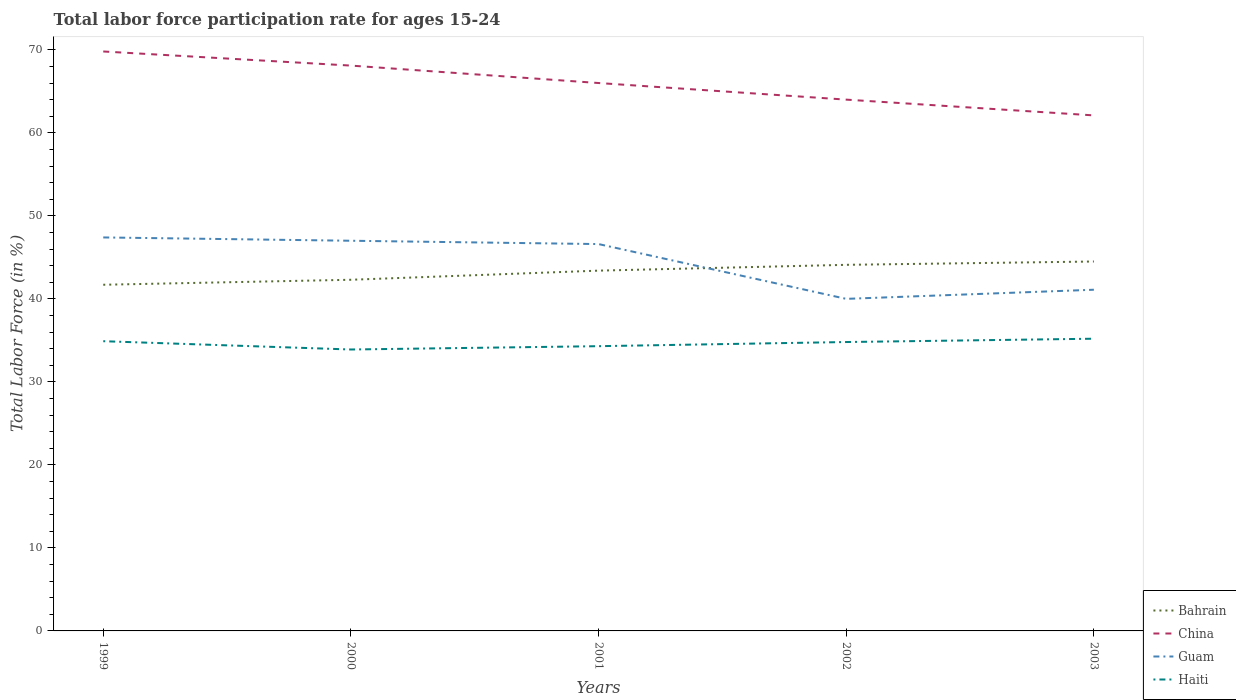How many different coloured lines are there?
Ensure brevity in your answer.  4. Is the number of lines equal to the number of legend labels?
Provide a succinct answer. Yes. Across all years, what is the maximum labor force participation rate in Bahrain?
Your answer should be compact. 41.7. In which year was the labor force participation rate in Guam maximum?
Your response must be concise. 2002. What is the total labor force participation rate in Haiti in the graph?
Offer a terse response. 0.6. What is the difference between the highest and the second highest labor force participation rate in Guam?
Offer a terse response. 7.4. What is the difference between the highest and the lowest labor force participation rate in China?
Offer a very short reply. 3. Is the labor force participation rate in China strictly greater than the labor force participation rate in Bahrain over the years?
Provide a succinct answer. No. How many years are there in the graph?
Provide a short and direct response. 5. What is the difference between two consecutive major ticks on the Y-axis?
Make the answer very short. 10. Are the values on the major ticks of Y-axis written in scientific E-notation?
Keep it short and to the point. No. Does the graph contain grids?
Your answer should be very brief. No. How many legend labels are there?
Provide a succinct answer. 4. How are the legend labels stacked?
Provide a succinct answer. Vertical. What is the title of the graph?
Give a very brief answer. Total labor force participation rate for ages 15-24. Does "Mexico" appear as one of the legend labels in the graph?
Provide a succinct answer. No. What is the Total Labor Force (in %) in Bahrain in 1999?
Your answer should be very brief. 41.7. What is the Total Labor Force (in %) in China in 1999?
Your answer should be compact. 69.8. What is the Total Labor Force (in %) of Guam in 1999?
Ensure brevity in your answer.  47.4. What is the Total Labor Force (in %) in Haiti in 1999?
Your answer should be very brief. 34.9. What is the Total Labor Force (in %) of Bahrain in 2000?
Your response must be concise. 42.3. What is the Total Labor Force (in %) in China in 2000?
Your response must be concise. 68.1. What is the Total Labor Force (in %) in Haiti in 2000?
Ensure brevity in your answer.  33.9. What is the Total Labor Force (in %) in Bahrain in 2001?
Provide a succinct answer. 43.4. What is the Total Labor Force (in %) in China in 2001?
Provide a succinct answer. 66. What is the Total Labor Force (in %) in Guam in 2001?
Offer a terse response. 46.6. What is the Total Labor Force (in %) in Haiti in 2001?
Give a very brief answer. 34.3. What is the Total Labor Force (in %) of Bahrain in 2002?
Your answer should be very brief. 44.1. What is the Total Labor Force (in %) in China in 2002?
Keep it short and to the point. 64. What is the Total Labor Force (in %) in Guam in 2002?
Make the answer very short. 40. What is the Total Labor Force (in %) in Haiti in 2002?
Provide a succinct answer. 34.8. What is the Total Labor Force (in %) of Bahrain in 2003?
Give a very brief answer. 44.5. What is the Total Labor Force (in %) of China in 2003?
Ensure brevity in your answer.  62.1. What is the Total Labor Force (in %) in Guam in 2003?
Offer a terse response. 41.1. What is the Total Labor Force (in %) in Haiti in 2003?
Keep it short and to the point. 35.2. Across all years, what is the maximum Total Labor Force (in %) of Bahrain?
Provide a succinct answer. 44.5. Across all years, what is the maximum Total Labor Force (in %) in China?
Ensure brevity in your answer.  69.8. Across all years, what is the maximum Total Labor Force (in %) in Guam?
Offer a very short reply. 47.4. Across all years, what is the maximum Total Labor Force (in %) of Haiti?
Make the answer very short. 35.2. Across all years, what is the minimum Total Labor Force (in %) of Bahrain?
Make the answer very short. 41.7. Across all years, what is the minimum Total Labor Force (in %) in China?
Your response must be concise. 62.1. Across all years, what is the minimum Total Labor Force (in %) of Guam?
Keep it short and to the point. 40. Across all years, what is the minimum Total Labor Force (in %) of Haiti?
Make the answer very short. 33.9. What is the total Total Labor Force (in %) in Bahrain in the graph?
Your response must be concise. 216. What is the total Total Labor Force (in %) in China in the graph?
Your response must be concise. 330. What is the total Total Labor Force (in %) in Guam in the graph?
Ensure brevity in your answer.  222.1. What is the total Total Labor Force (in %) in Haiti in the graph?
Offer a terse response. 173.1. What is the difference between the Total Labor Force (in %) in China in 1999 and that in 2000?
Provide a succinct answer. 1.7. What is the difference between the Total Labor Force (in %) in Haiti in 1999 and that in 2000?
Keep it short and to the point. 1. What is the difference between the Total Labor Force (in %) in Bahrain in 1999 and that in 2001?
Ensure brevity in your answer.  -1.7. What is the difference between the Total Labor Force (in %) of Guam in 1999 and that in 2001?
Provide a short and direct response. 0.8. What is the difference between the Total Labor Force (in %) in Bahrain in 1999 and that in 2002?
Keep it short and to the point. -2.4. What is the difference between the Total Labor Force (in %) in Bahrain in 1999 and that in 2003?
Give a very brief answer. -2.8. What is the difference between the Total Labor Force (in %) in China in 1999 and that in 2003?
Offer a very short reply. 7.7. What is the difference between the Total Labor Force (in %) in Haiti in 1999 and that in 2003?
Make the answer very short. -0.3. What is the difference between the Total Labor Force (in %) in China in 2000 and that in 2001?
Make the answer very short. 2.1. What is the difference between the Total Labor Force (in %) in Haiti in 2000 and that in 2001?
Keep it short and to the point. -0.4. What is the difference between the Total Labor Force (in %) in Bahrain in 2000 and that in 2002?
Keep it short and to the point. -1.8. What is the difference between the Total Labor Force (in %) of China in 2000 and that in 2002?
Provide a succinct answer. 4.1. What is the difference between the Total Labor Force (in %) of Guam in 2000 and that in 2002?
Provide a succinct answer. 7. What is the difference between the Total Labor Force (in %) in Haiti in 2000 and that in 2002?
Your answer should be very brief. -0.9. What is the difference between the Total Labor Force (in %) of China in 2000 and that in 2003?
Keep it short and to the point. 6. What is the difference between the Total Labor Force (in %) of Guam in 2000 and that in 2003?
Make the answer very short. 5.9. What is the difference between the Total Labor Force (in %) of Haiti in 2000 and that in 2003?
Ensure brevity in your answer.  -1.3. What is the difference between the Total Labor Force (in %) in Haiti in 2001 and that in 2002?
Your answer should be compact. -0.5. What is the difference between the Total Labor Force (in %) in Guam in 2001 and that in 2003?
Offer a terse response. 5.5. What is the difference between the Total Labor Force (in %) in Guam in 2002 and that in 2003?
Provide a succinct answer. -1.1. What is the difference between the Total Labor Force (in %) in Haiti in 2002 and that in 2003?
Provide a short and direct response. -0.4. What is the difference between the Total Labor Force (in %) in Bahrain in 1999 and the Total Labor Force (in %) in China in 2000?
Your answer should be compact. -26.4. What is the difference between the Total Labor Force (in %) in Bahrain in 1999 and the Total Labor Force (in %) in Guam in 2000?
Ensure brevity in your answer.  -5.3. What is the difference between the Total Labor Force (in %) in Bahrain in 1999 and the Total Labor Force (in %) in Haiti in 2000?
Give a very brief answer. 7.8. What is the difference between the Total Labor Force (in %) in China in 1999 and the Total Labor Force (in %) in Guam in 2000?
Give a very brief answer. 22.8. What is the difference between the Total Labor Force (in %) of China in 1999 and the Total Labor Force (in %) of Haiti in 2000?
Make the answer very short. 35.9. What is the difference between the Total Labor Force (in %) of Guam in 1999 and the Total Labor Force (in %) of Haiti in 2000?
Your answer should be very brief. 13.5. What is the difference between the Total Labor Force (in %) of Bahrain in 1999 and the Total Labor Force (in %) of China in 2001?
Your answer should be very brief. -24.3. What is the difference between the Total Labor Force (in %) in Bahrain in 1999 and the Total Labor Force (in %) in Haiti in 2001?
Make the answer very short. 7.4. What is the difference between the Total Labor Force (in %) of China in 1999 and the Total Labor Force (in %) of Guam in 2001?
Offer a very short reply. 23.2. What is the difference between the Total Labor Force (in %) of China in 1999 and the Total Labor Force (in %) of Haiti in 2001?
Ensure brevity in your answer.  35.5. What is the difference between the Total Labor Force (in %) of Guam in 1999 and the Total Labor Force (in %) of Haiti in 2001?
Your answer should be very brief. 13.1. What is the difference between the Total Labor Force (in %) in Bahrain in 1999 and the Total Labor Force (in %) in China in 2002?
Your answer should be very brief. -22.3. What is the difference between the Total Labor Force (in %) in China in 1999 and the Total Labor Force (in %) in Guam in 2002?
Make the answer very short. 29.8. What is the difference between the Total Labor Force (in %) in China in 1999 and the Total Labor Force (in %) in Haiti in 2002?
Your response must be concise. 35. What is the difference between the Total Labor Force (in %) in Guam in 1999 and the Total Labor Force (in %) in Haiti in 2002?
Make the answer very short. 12.6. What is the difference between the Total Labor Force (in %) of Bahrain in 1999 and the Total Labor Force (in %) of China in 2003?
Make the answer very short. -20.4. What is the difference between the Total Labor Force (in %) of China in 1999 and the Total Labor Force (in %) of Guam in 2003?
Give a very brief answer. 28.7. What is the difference between the Total Labor Force (in %) in China in 1999 and the Total Labor Force (in %) in Haiti in 2003?
Ensure brevity in your answer.  34.6. What is the difference between the Total Labor Force (in %) in Guam in 1999 and the Total Labor Force (in %) in Haiti in 2003?
Keep it short and to the point. 12.2. What is the difference between the Total Labor Force (in %) in Bahrain in 2000 and the Total Labor Force (in %) in China in 2001?
Your response must be concise. -23.7. What is the difference between the Total Labor Force (in %) of China in 2000 and the Total Labor Force (in %) of Guam in 2001?
Make the answer very short. 21.5. What is the difference between the Total Labor Force (in %) in China in 2000 and the Total Labor Force (in %) in Haiti in 2001?
Give a very brief answer. 33.8. What is the difference between the Total Labor Force (in %) in Guam in 2000 and the Total Labor Force (in %) in Haiti in 2001?
Your answer should be compact. 12.7. What is the difference between the Total Labor Force (in %) of Bahrain in 2000 and the Total Labor Force (in %) of China in 2002?
Your answer should be compact. -21.7. What is the difference between the Total Labor Force (in %) of China in 2000 and the Total Labor Force (in %) of Guam in 2002?
Ensure brevity in your answer.  28.1. What is the difference between the Total Labor Force (in %) of China in 2000 and the Total Labor Force (in %) of Haiti in 2002?
Give a very brief answer. 33.3. What is the difference between the Total Labor Force (in %) of Guam in 2000 and the Total Labor Force (in %) of Haiti in 2002?
Provide a succinct answer. 12.2. What is the difference between the Total Labor Force (in %) in Bahrain in 2000 and the Total Labor Force (in %) in China in 2003?
Offer a terse response. -19.8. What is the difference between the Total Labor Force (in %) in Bahrain in 2000 and the Total Labor Force (in %) in Guam in 2003?
Make the answer very short. 1.2. What is the difference between the Total Labor Force (in %) in Bahrain in 2000 and the Total Labor Force (in %) in Haiti in 2003?
Make the answer very short. 7.1. What is the difference between the Total Labor Force (in %) of China in 2000 and the Total Labor Force (in %) of Guam in 2003?
Your answer should be very brief. 27. What is the difference between the Total Labor Force (in %) in China in 2000 and the Total Labor Force (in %) in Haiti in 2003?
Provide a succinct answer. 32.9. What is the difference between the Total Labor Force (in %) in Bahrain in 2001 and the Total Labor Force (in %) in China in 2002?
Keep it short and to the point. -20.6. What is the difference between the Total Labor Force (in %) in Bahrain in 2001 and the Total Labor Force (in %) in Haiti in 2002?
Provide a succinct answer. 8.6. What is the difference between the Total Labor Force (in %) in China in 2001 and the Total Labor Force (in %) in Haiti in 2002?
Offer a very short reply. 31.2. What is the difference between the Total Labor Force (in %) in Guam in 2001 and the Total Labor Force (in %) in Haiti in 2002?
Offer a very short reply. 11.8. What is the difference between the Total Labor Force (in %) of Bahrain in 2001 and the Total Labor Force (in %) of China in 2003?
Provide a short and direct response. -18.7. What is the difference between the Total Labor Force (in %) of China in 2001 and the Total Labor Force (in %) of Guam in 2003?
Offer a terse response. 24.9. What is the difference between the Total Labor Force (in %) in China in 2001 and the Total Labor Force (in %) in Haiti in 2003?
Your response must be concise. 30.8. What is the difference between the Total Labor Force (in %) of Bahrain in 2002 and the Total Labor Force (in %) of China in 2003?
Your answer should be very brief. -18. What is the difference between the Total Labor Force (in %) of Bahrain in 2002 and the Total Labor Force (in %) of Haiti in 2003?
Provide a short and direct response. 8.9. What is the difference between the Total Labor Force (in %) of China in 2002 and the Total Labor Force (in %) of Guam in 2003?
Provide a succinct answer. 22.9. What is the difference between the Total Labor Force (in %) in China in 2002 and the Total Labor Force (in %) in Haiti in 2003?
Provide a succinct answer. 28.8. What is the average Total Labor Force (in %) in Bahrain per year?
Your response must be concise. 43.2. What is the average Total Labor Force (in %) in Guam per year?
Your answer should be very brief. 44.42. What is the average Total Labor Force (in %) of Haiti per year?
Provide a succinct answer. 34.62. In the year 1999, what is the difference between the Total Labor Force (in %) of Bahrain and Total Labor Force (in %) of China?
Your answer should be compact. -28.1. In the year 1999, what is the difference between the Total Labor Force (in %) in China and Total Labor Force (in %) in Guam?
Keep it short and to the point. 22.4. In the year 1999, what is the difference between the Total Labor Force (in %) of China and Total Labor Force (in %) of Haiti?
Keep it short and to the point. 34.9. In the year 2000, what is the difference between the Total Labor Force (in %) in Bahrain and Total Labor Force (in %) in China?
Offer a very short reply. -25.8. In the year 2000, what is the difference between the Total Labor Force (in %) in China and Total Labor Force (in %) in Guam?
Your response must be concise. 21.1. In the year 2000, what is the difference between the Total Labor Force (in %) of China and Total Labor Force (in %) of Haiti?
Your response must be concise. 34.2. In the year 2001, what is the difference between the Total Labor Force (in %) of Bahrain and Total Labor Force (in %) of China?
Your response must be concise. -22.6. In the year 2001, what is the difference between the Total Labor Force (in %) of Bahrain and Total Labor Force (in %) of Haiti?
Provide a succinct answer. 9.1. In the year 2001, what is the difference between the Total Labor Force (in %) in China and Total Labor Force (in %) in Haiti?
Give a very brief answer. 31.7. In the year 2002, what is the difference between the Total Labor Force (in %) in Bahrain and Total Labor Force (in %) in China?
Offer a very short reply. -19.9. In the year 2002, what is the difference between the Total Labor Force (in %) in Bahrain and Total Labor Force (in %) in Guam?
Offer a terse response. 4.1. In the year 2002, what is the difference between the Total Labor Force (in %) in Bahrain and Total Labor Force (in %) in Haiti?
Offer a terse response. 9.3. In the year 2002, what is the difference between the Total Labor Force (in %) of China and Total Labor Force (in %) of Guam?
Give a very brief answer. 24. In the year 2002, what is the difference between the Total Labor Force (in %) in China and Total Labor Force (in %) in Haiti?
Provide a succinct answer. 29.2. In the year 2003, what is the difference between the Total Labor Force (in %) in Bahrain and Total Labor Force (in %) in China?
Your answer should be compact. -17.6. In the year 2003, what is the difference between the Total Labor Force (in %) in Bahrain and Total Labor Force (in %) in Guam?
Keep it short and to the point. 3.4. In the year 2003, what is the difference between the Total Labor Force (in %) in China and Total Labor Force (in %) in Guam?
Your answer should be very brief. 21. In the year 2003, what is the difference between the Total Labor Force (in %) of China and Total Labor Force (in %) of Haiti?
Keep it short and to the point. 26.9. In the year 2003, what is the difference between the Total Labor Force (in %) in Guam and Total Labor Force (in %) in Haiti?
Provide a succinct answer. 5.9. What is the ratio of the Total Labor Force (in %) of Bahrain in 1999 to that in 2000?
Provide a short and direct response. 0.99. What is the ratio of the Total Labor Force (in %) of Guam in 1999 to that in 2000?
Offer a terse response. 1.01. What is the ratio of the Total Labor Force (in %) of Haiti in 1999 to that in 2000?
Make the answer very short. 1.03. What is the ratio of the Total Labor Force (in %) of Bahrain in 1999 to that in 2001?
Provide a short and direct response. 0.96. What is the ratio of the Total Labor Force (in %) in China in 1999 to that in 2001?
Keep it short and to the point. 1.06. What is the ratio of the Total Labor Force (in %) of Guam in 1999 to that in 2001?
Offer a terse response. 1.02. What is the ratio of the Total Labor Force (in %) of Haiti in 1999 to that in 2001?
Provide a short and direct response. 1.02. What is the ratio of the Total Labor Force (in %) of Bahrain in 1999 to that in 2002?
Make the answer very short. 0.95. What is the ratio of the Total Labor Force (in %) of China in 1999 to that in 2002?
Your answer should be compact. 1.09. What is the ratio of the Total Labor Force (in %) in Guam in 1999 to that in 2002?
Provide a short and direct response. 1.19. What is the ratio of the Total Labor Force (in %) of Bahrain in 1999 to that in 2003?
Your response must be concise. 0.94. What is the ratio of the Total Labor Force (in %) in China in 1999 to that in 2003?
Provide a short and direct response. 1.12. What is the ratio of the Total Labor Force (in %) of Guam in 1999 to that in 2003?
Your answer should be compact. 1.15. What is the ratio of the Total Labor Force (in %) of Bahrain in 2000 to that in 2001?
Give a very brief answer. 0.97. What is the ratio of the Total Labor Force (in %) of China in 2000 to that in 2001?
Give a very brief answer. 1.03. What is the ratio of the Total Labor Force (in %) in Guam in 2000 to that in 2001?
Give a very brief answer. 1.01. What is the ratio of the Total Labor Force (in %) of Haiti in 2000 to that in 2001?
Provide a short and direct response. 0.99. What is the ratio of the Total Labor Force (in %) in Bahrain in 2000 to that in 2002?
Ensure brevity in your answer.  0.96. What is the ratio of the Total Labor Force (in %) of China in 2000 to that in 2002?
Offer a very short reply. 1.06. What is the ratio of the Total Labor Force (in %) in Guam in 2000 to that in 2002?
Provide a succinct answer. 1.18. What is the ratio of the Total Labor Force (in %) of Haiti in 2000 to that in 2002?
Your answer should be compact. 0.97. What is the ratio of the Total Labor Force (in %) in Bahrain in 2000 to that in 2003?
Your answer should be compact. 0.95. What is the ratio of the Total Labor Force (in %) of China in 2000 to that in 2003?
Your answer should be compact. 1.1. What is the ratio of the Total Labor Force (in %) of Guam in 2000 to that in 2003?
Give a very brief answer. 1.14. What is the ratio of the Total Labor Force (in %) in Haiti in 2000 to that in 2003?
Your answer should be very brief. 0.96. What is the ratio of the Total Labor Force (in %) in Bahrain in 2001 to that in 2002?
Offer a terse response. 0.98. What is the ratio of the Total Labor Force (in %) in China in 2001 to that in 2002?
Ensure brevity in your answer.  1.03. What is the ratio of the Total Labor Force (in %) in Guam in 2001 to that in 2002?
Provide a short and direct response. 1.17. What is the ratio of the Total Labor Force (in %) in Haiti in 2001 to that in 2002?
Your response must be concise. 0.99. What is the ratio of the Total Labor Force (in %) of Bahrain in 2001 to that in 2003?
Make the answer very short. 0.98. What is the ratio of the Total Labor Force (in %) of China in 2001 to that in 2003?
Provide a succinct answer. 1.06. What is the ratio of the Total Labor Force (in %) of Guam in 2001 to that in 2003?
Offer a terse response. 1.13. What is the ratio of the Total Labor Force (in %) of Haiti in 2001 to that in 2003?
Keep it short and to the point. 0.97. What is the ratio of the Total Labor Force (in %) of Bahrain in 2002 to that in 2003?
Your response must be concise. 0.99. What is the ratio of the Total Labor Force (in %) of China in 2002 to that in 2003?
Make the answer very short. 1.03. What is the ratio of the Total Labor Force (in %) in Guam in 2002 to that in 2003?
Offer a very short reply. 0.97. What is the difference between the highest and the second highest Total Labor Force (in %) in Bahrain?
Your response must be concise. 0.4. What is the difference between the highest and the second highest Total Labor Force (in %) in Guam?
Your answer should be compact. 0.4. What is the difference between the highest and the second highest Total Labor Force (in %) of Haiti?
Offer a very short reply. 0.3. What is the difference between the highest and the lowest Total Labor Force (in %) in Bahrain?
Offer a terse response. 2.8. 